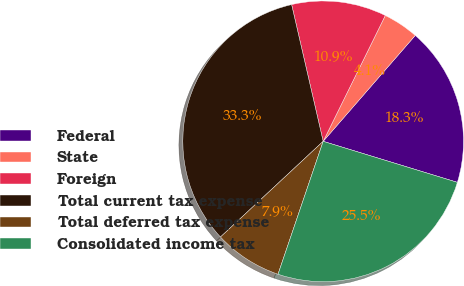<chart> <loc_0><loc_0><loc_500><loc_500><pie_chart><fcel>Federal<fcel>State<fcel>Foreign<fcel>Total current tax expense<fcel>Total deferred tax expense<fcel>Consolidated income tax<nl><fcel>18.33%<fcel>4.09%<fcel>10.91%<fcel>33.33%<fcel>7.85%<fcel>25.49%<nl></chart> 